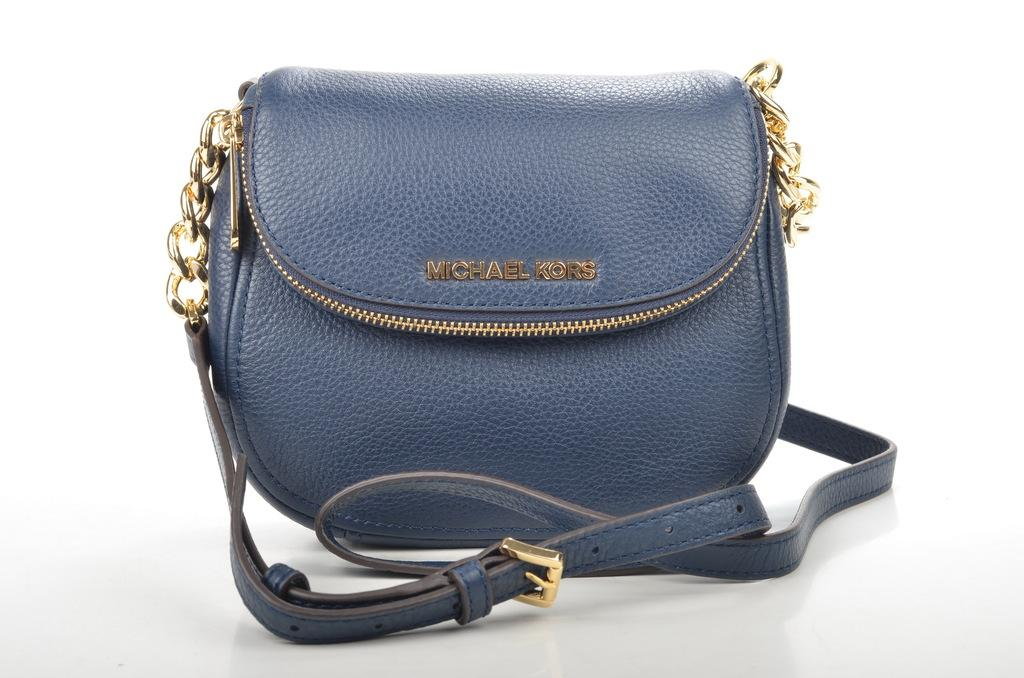What object is present in the image that can be used for carrying items? There is a bag in the image that can be used for carrying items. What feature is attached to the bag that might be used for securing it? The bag has a chain attached to it. What other accessory is connected to the bag? There is a belt attached to the bag. What month is depicted on the bag in the image? There is no indication of a month or any specific time element in the image. Can you see a horn attached to the bag in the image? There is no horn present on the bag in the image. 